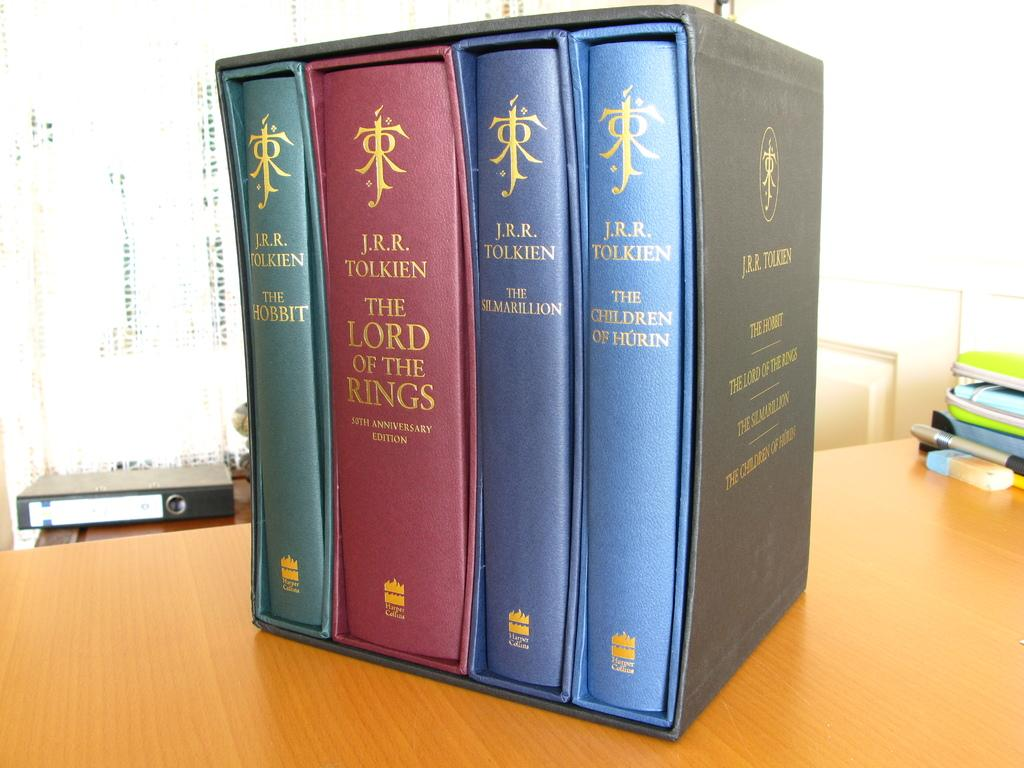<image>
Summarize the visual content of the image. Group of books that appear to be lord of the rings 